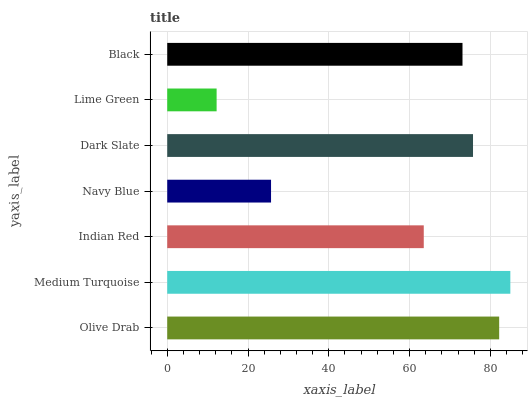Is Lime Green the minimum?
Answer yes or no. Yes. Is Medium Turquoise the maximum?
Answer yes or no. Yes. Is Indian Red the minimum?
Answer yes or no. No. Is Indian Red the maximum?
Answer yes or no. No. Is Medium Turquoise greater than Indian Red?
Answer yes or no. Yes. Is Indian Red less than Medium Turquoise?
Answer yes or no. Yes. Is Indian Red greater than Medium Turquoise?
Answer yes or no. No. Is Medium Turquoise less than Indian Red?
Answer yes or no. No. Is Black the high median?
Answer yes or no. Yes. Is Black the low median?
Answer yes or no. Yes. Is Medium Turquoise the high median?
Answer yes or no. No. Is Navy Blue the low median?
Answer yes or no. No. 